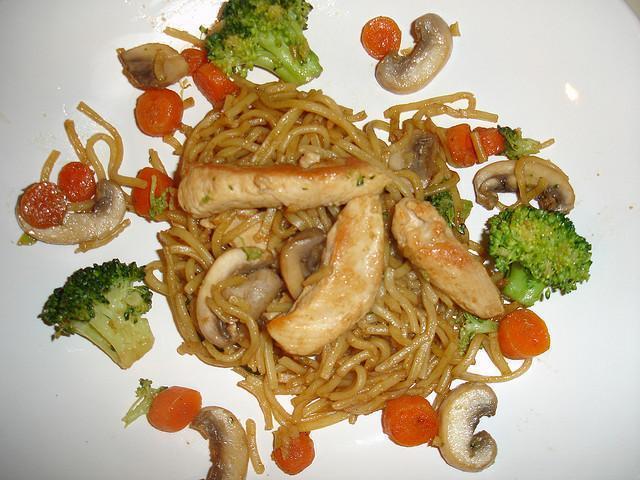How many piece of broccoli?
Give a very brief answer. 3. How many carrots are in the photo?
Give a very brief answer. 4. How many broccolis are there?
Give a very brief answer. 3. How many giraffes are in the picture?
Give a very brief answer. 0. 